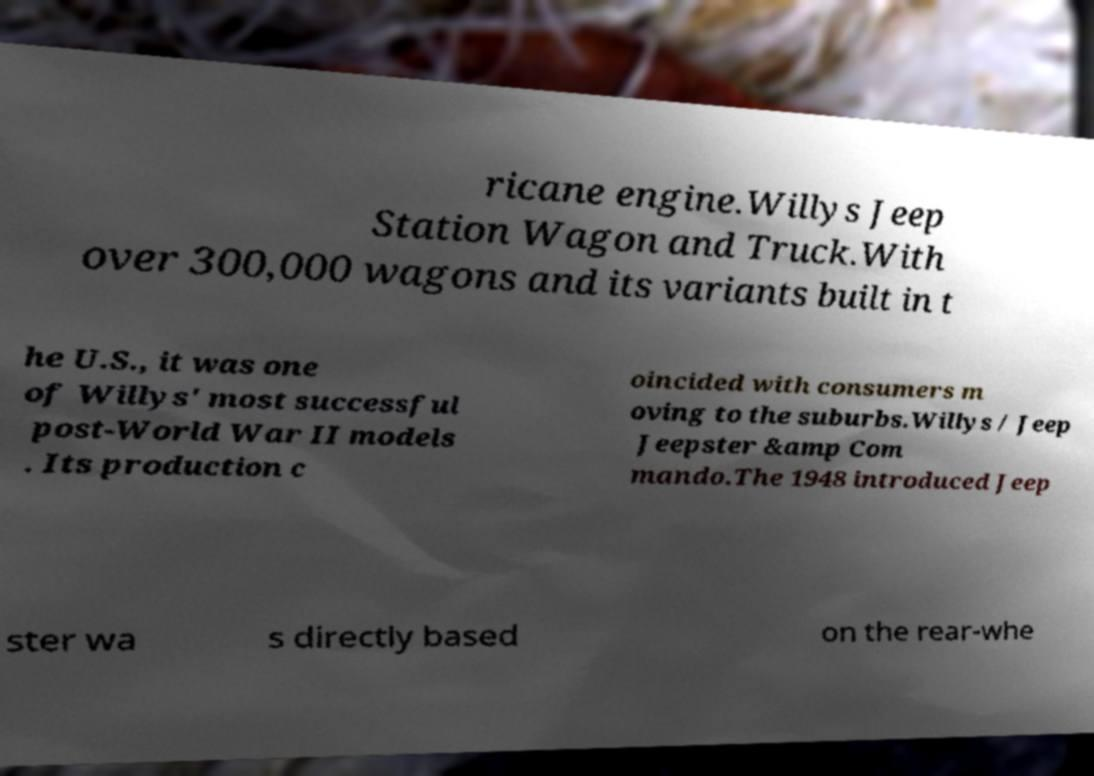Please identify and transcribe the text found in this image. ricane engine.Willys Jeep Station Wagon and Truck.With over 300,000 wagons and its variants built in t he U.S., it was one of Willys' most successful post-World War II models . Its production c oincided with consumers m oving to the suburbs.Willys / Jeep Jeepster &amp Com mando.The 1948 introduced Jeep ster wa s directly based on the rear-whe 